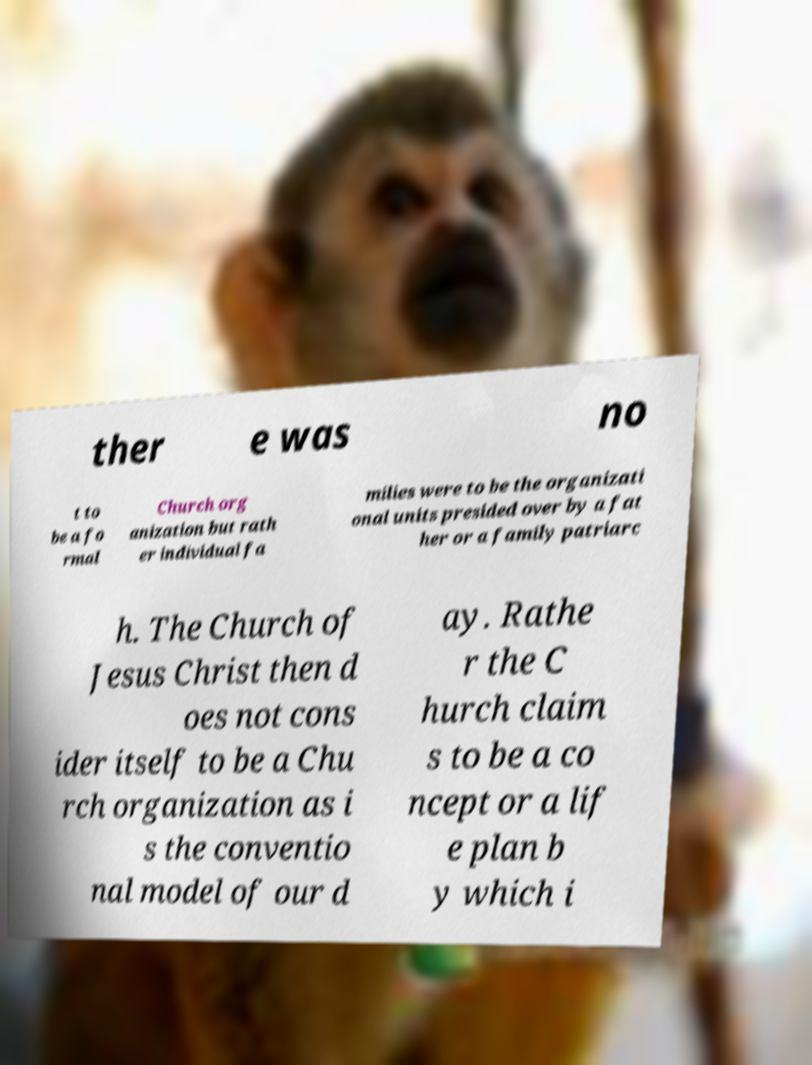What messages or text are displayed in this image? I need them in a readable, typed format. ther e was no t to be a fo rmal Church org anization but rath er individual fa milies were to be the organizati onal units presided over by a fat her or a family patriarc h. The Church of Jesus Christ then d oes not cons ider itself to be a Chu rch organization as i s the conventio nal model of our d ay. Rathe r the C hurch claim s to be a co ncept or a lif e plan b y which i 